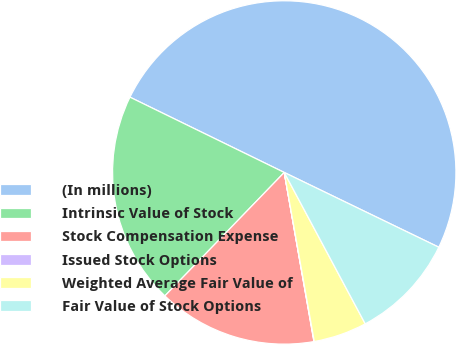Convert chart to OTSL. <chart><loc_0><loc_0><loc_500><loc_500><pie_chart><fcel>(In millions)<fcel>Intrinsic Value of Stock<fcel>Stock Compensation Expense<fcel>Issued Stock Options<fcel>Weighted Average Fair Value of<fcel>Fair Value of Stock Options<nl><fcel>49.94%<fcel>19.99%<fcel>15.0%<fcel>0.03%<fcel>5.02%<fcel>10.01%<nl></chart> 